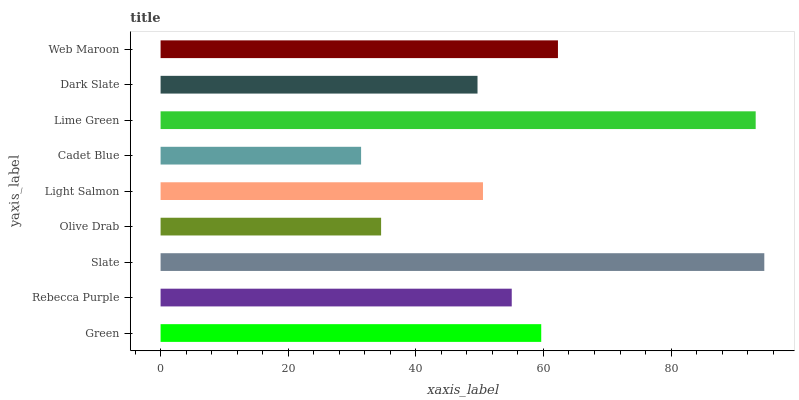Is Cadet Blue the minimum?
Answer yes or no. Yes. Is Slate the maximum?
Answer yes or no. Yes. Is Rebecca Purple the minimum?
Answer yes or no. No. Is Rebecca Purple the maximum?
Answer yes or no. No. Is Green greater than Rebecca Purple?
Answer yes or no. Yes. Is Rebecca Purple less than Green?
Answer yes or no. Yes. Is Rebecca Purple greater than Green?
Answer yes or no. No. Is Green less than Rebecca Purple?
Answer yes or no. No. Is Rebecca Purple the high median?
Answer yes or no. Yes. Is Rebecca Purple the low median?
Answer yes or no. Yes. Is Green the high median?
Answer yes or no. No. Is Dark Slate the low median?
Answer yes or no. No. 